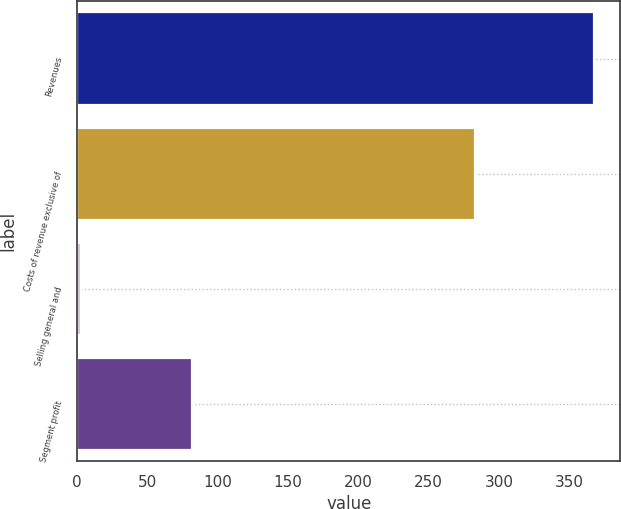<chart> <loc_0><loc_0><loc_500><loc_500><bar_chart><fcel>Revenues<fcel>Costs of revenue exclusive of<fcel>Selling general and<fcel>Segment profit<nl><fcel>368<fcel>283<fcel>3<fcel>82<nl></chart> 